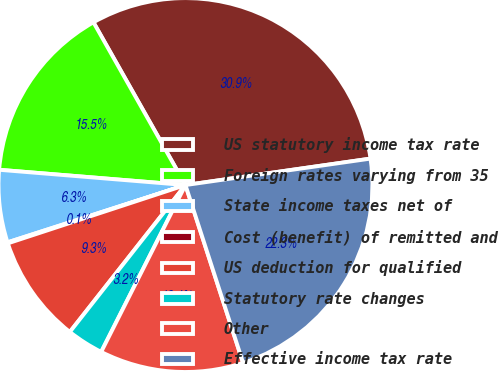<chart> <loc_0><loc_0><loc_500><loc_500><pie_chart><fcel>US statutory income tax rate<fcel>Foreign rates varying from 35<fcel>State income taxes net of<fcel>Cost (benefit) of remitted and<fcel>US deduction for qualified<fcel>Statutory rate changes<fcel>Other<fcel>Effective income tax rate<nl><fcel>30.93%<fcel>15.51%<fcel>6.26%<fcel>0.09%<fcel>9.34%<fcel>3.17%<fcel>12.43%<fcel>22.27%<nl></chart> 